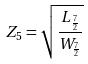Convert formula to latex. <formula><loc_0><loc_0><loc_500><loc_500>Z _ { 5 } = \sqrt { \frac { L _ { \frac { 7 } { 2 } } } { W _ { \frac { 7 } { 2 } } } }</formula> 